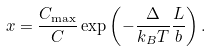<formula> <loc_0><loc_0><loc_500><loc_500>x = \frac { C _ { \max } } { C } \exp \left ( - \frac { \Delta } { k _ { B } T } \frac { L } { b } \right ) .</formula> 